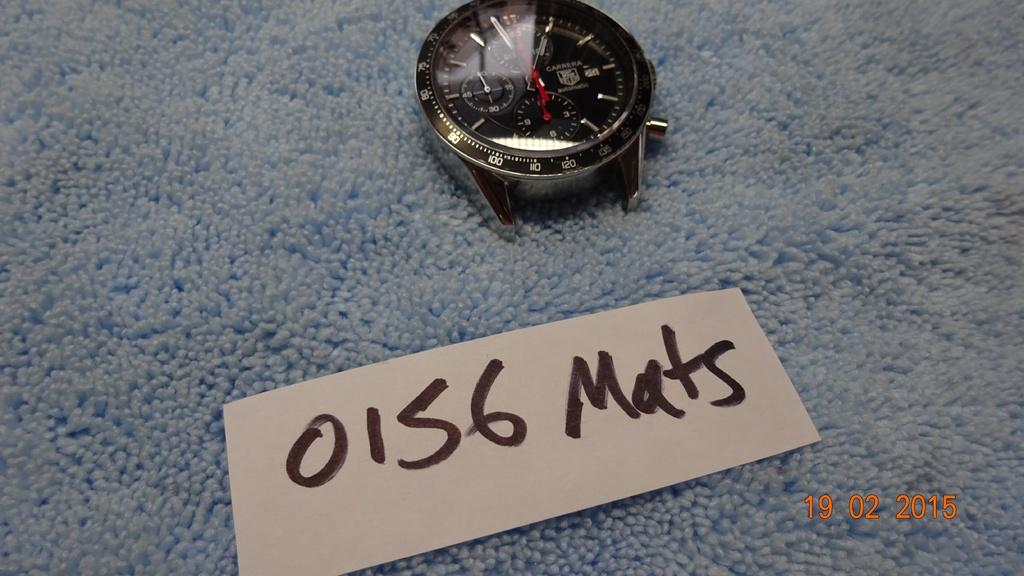<image>
Render a clear and concise summary of the photo. A watch sits near a card that says 0156 Mats. 